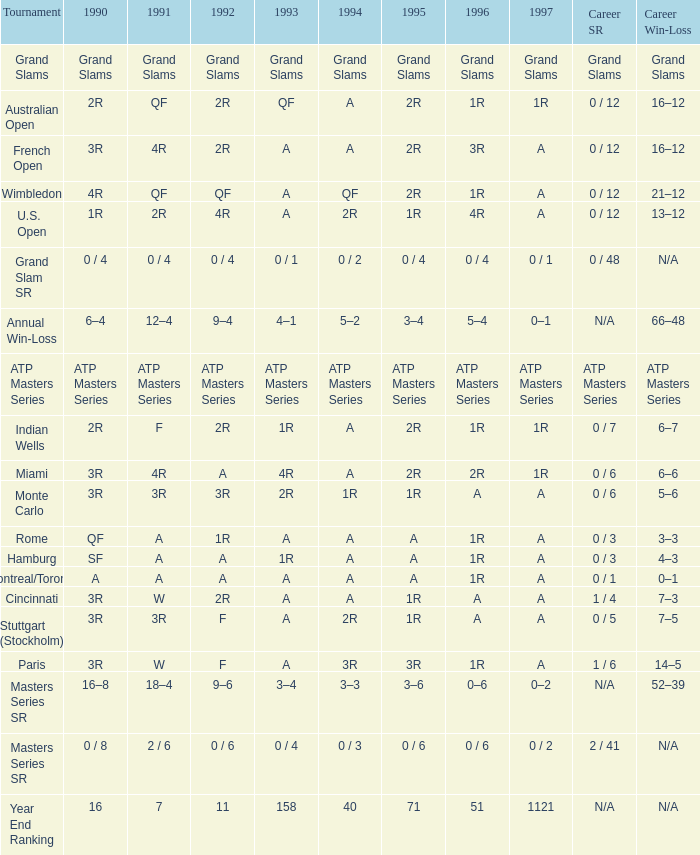What is 1996, when 1992 is "atp masters tournament"? ATP Masters Series. 